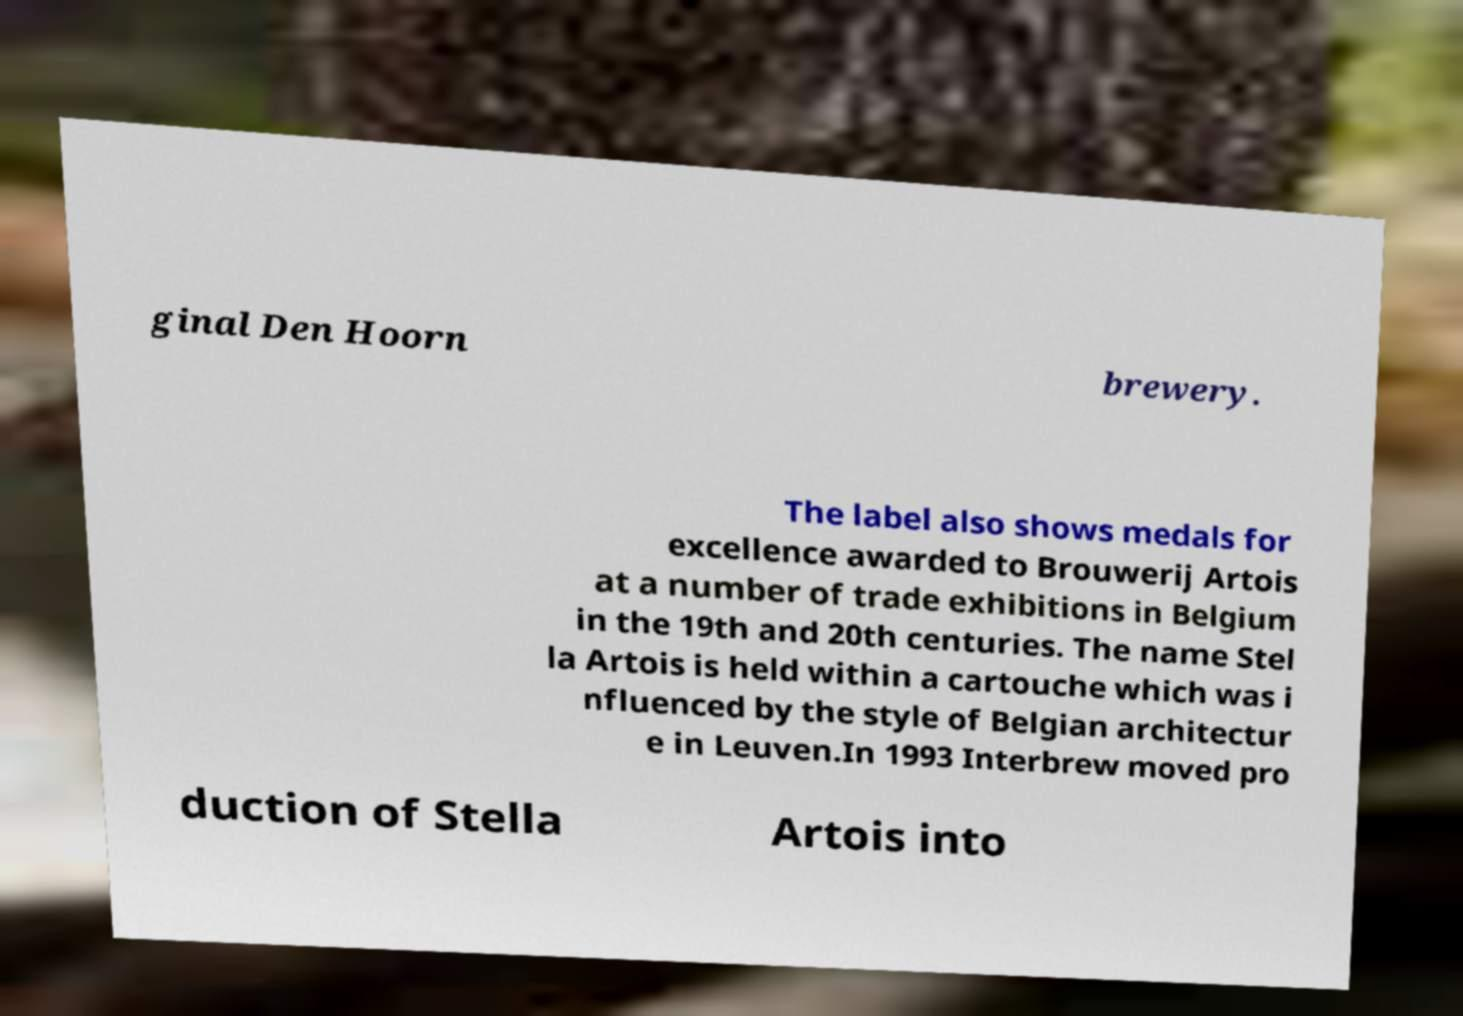Can you read and provide the text displayed in the image?This photo seems to have some interesting text. Can you extract and type it out for me? ginal Den Hoorn brewery. The label also shows medals for excellence awarded to Brouwerij Artois at a number of trade exhibitions in Belgium in the 19th and 20th centuries. The name Stel la Artois is held within a cartouche which was i nfluenced by the style of Belgian architectur e in Leuven.In 1993 Interbrew moved pro duction of Stella Artois into 